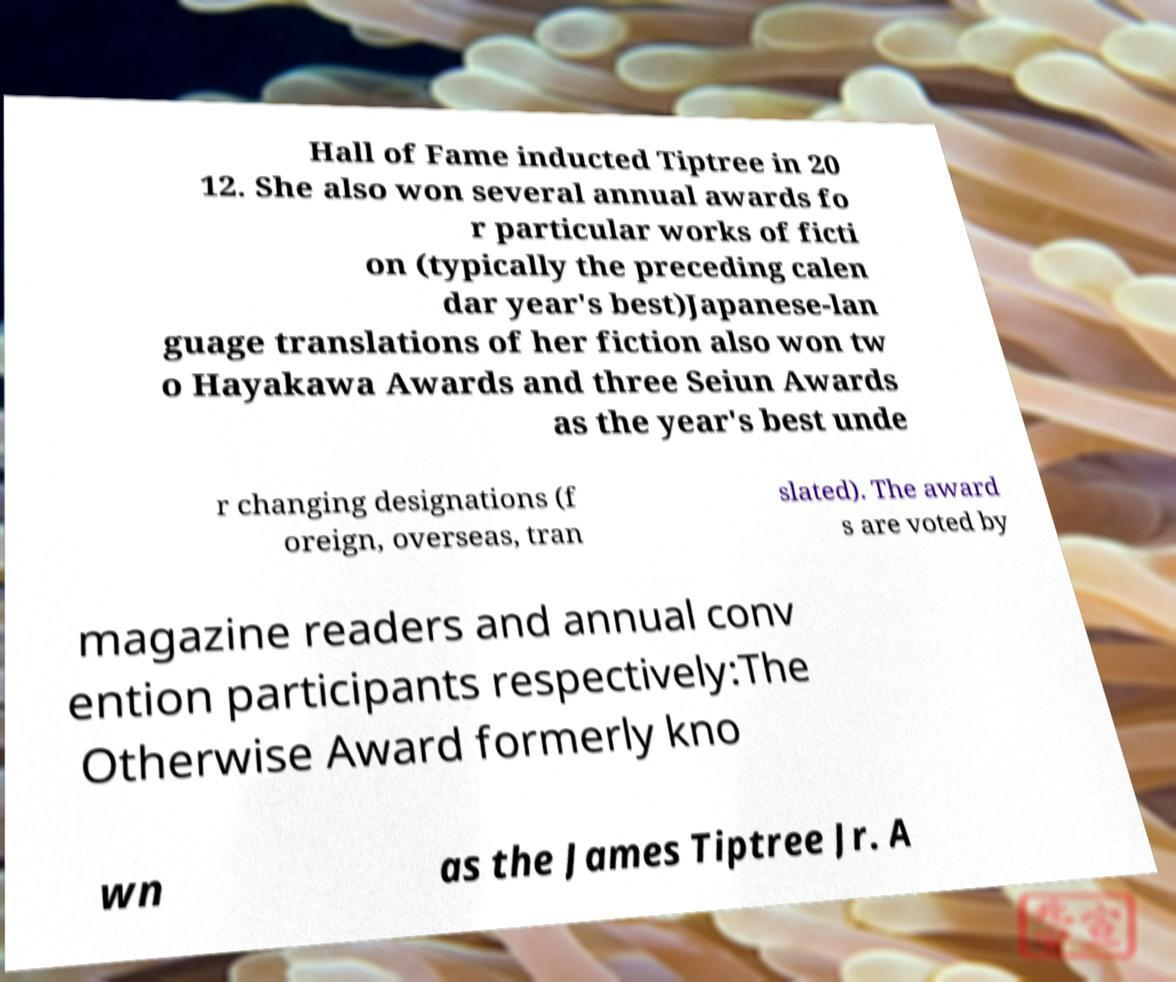Please read and relay the text visible in this image. What does it say? Hall of Fame inducted Tiptree in 20 12. She also won several annual awards fo r particular works of ficti on (typically the preceding calen dar year's best)Japanese-lan guage translations of her fiction also won tw o Hayakawa Awards and three Seiun Awards as the year's best unde r changing designations (f oreign, overseas, tran slated). The award s are voted by magazine readers and annual conv ention participants respectively:The Otherwise Award formerly kno wn as the James Tiptree Jr. A 